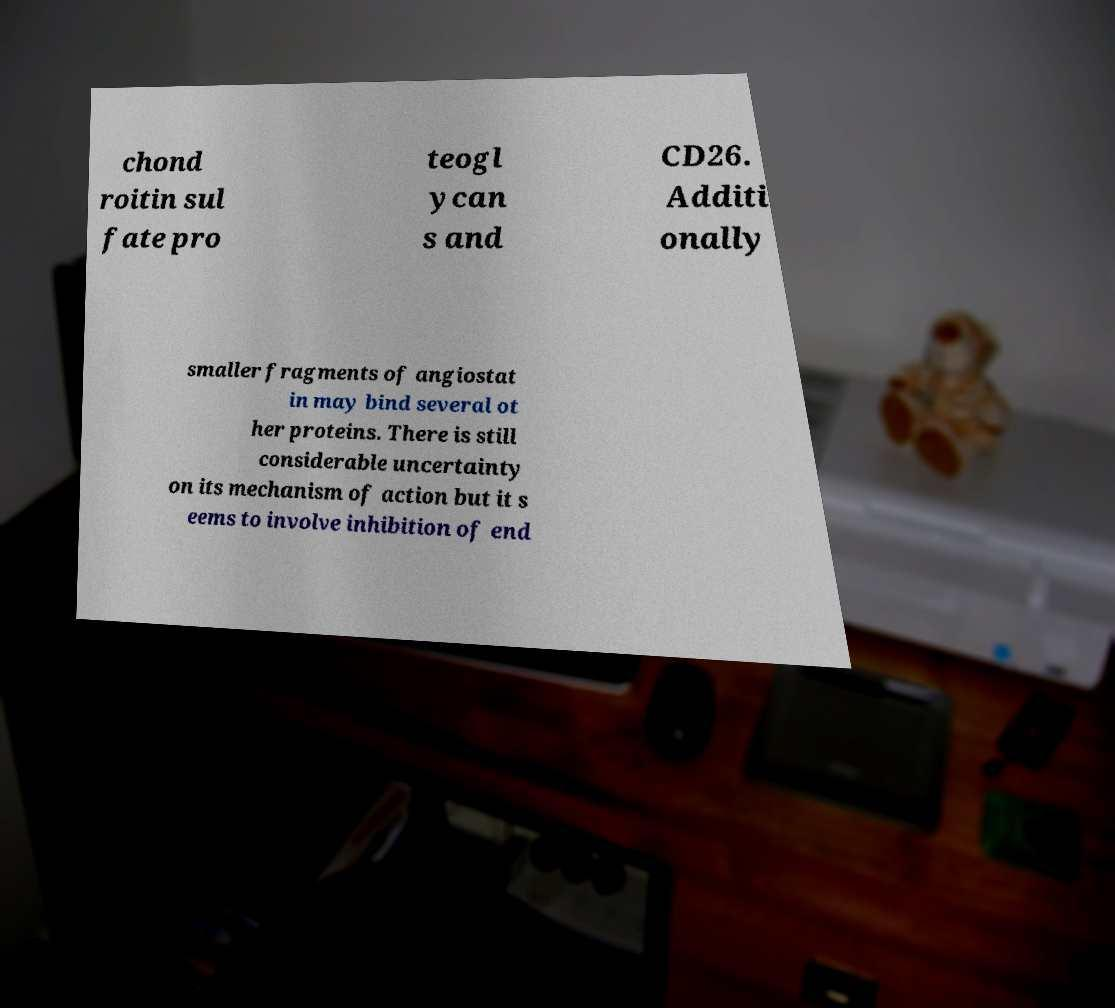Could you assist in decoding the text presented in this image and type it out clearly? chond roitin sul fate pro teogl ycan s and CD26. Additi onally smaller fragments of angiostat in may bind several ot her proteins. There is still considerable uncertainty on its mechanism of action but it s eems to involve inhibition of end 